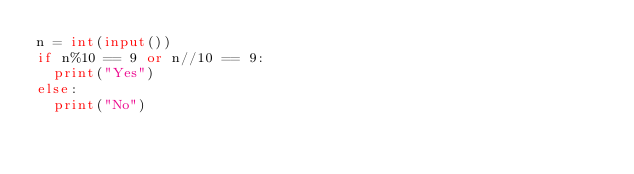<code> <loc_0><loc_0><loc_500><loc_500><_Python_>n = int(input())
if n%10 == 9 or n//10 == 9:
  print("Yes")
else:
  print("No")</code> 